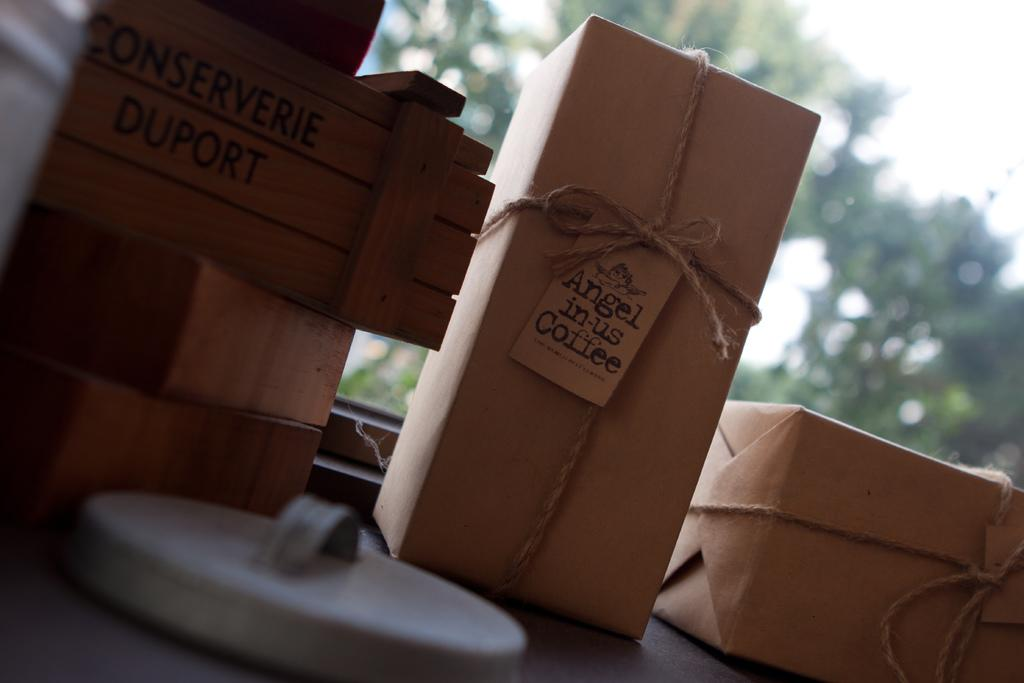What objects are located in the front of the image? There are boxes in the front of the image. What information is provided on the boxes? There is text written on the boxes. What type of natural scenery can be seen in the background of the image? There are trees in the background of the image. How many boys are playing in the background of the image? There are no boys present in the image; it only features boxes with text and trees in the background. 